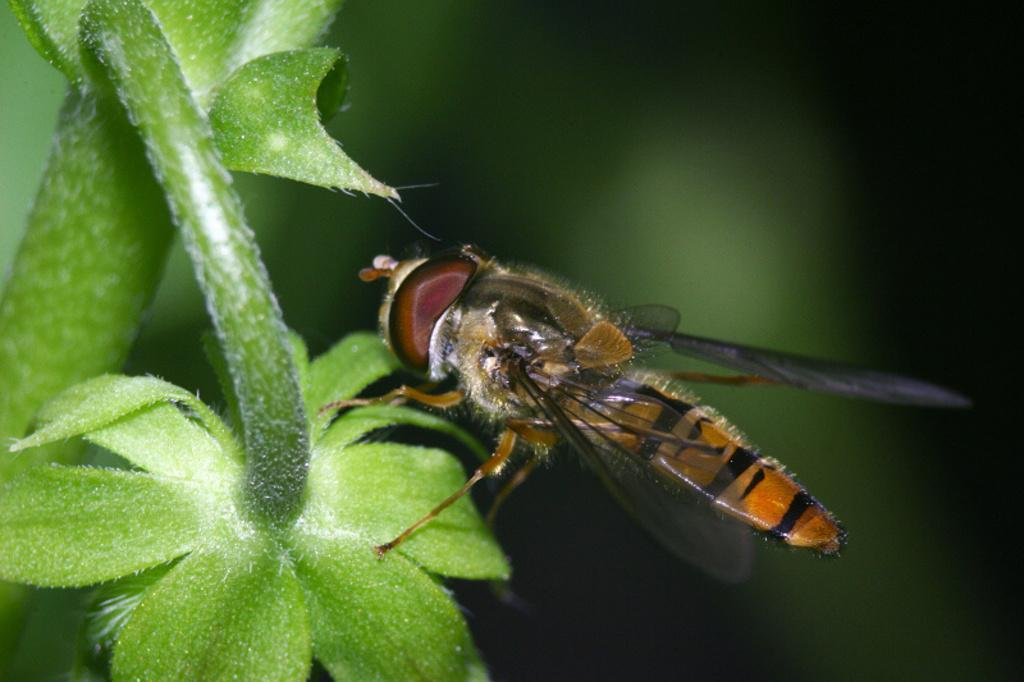What type of creature is present in the image? There is an insect in the image. Where is the insect located? The insect is on a plant. Can you describe the background of the image? The background of the image is blurred. How many men are seen falling from the pump in the image? There are no men or pumps present in the image; it features an insect on a plant with a blurred background. 